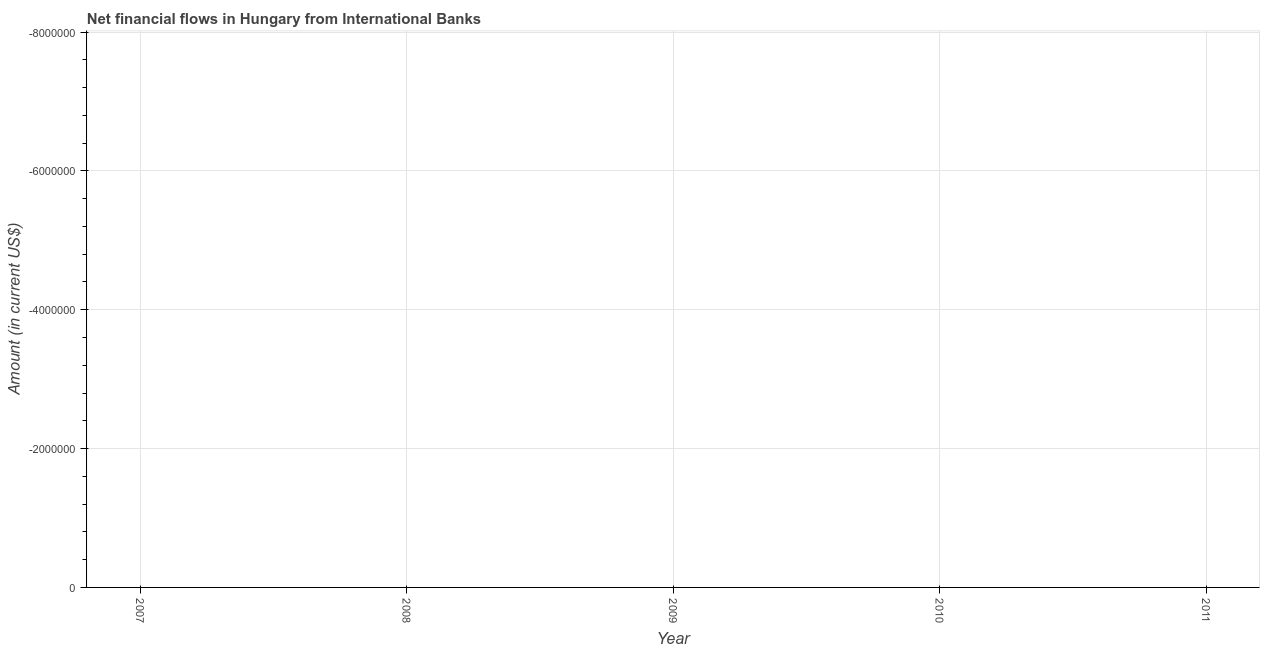Across all years, what is the minimum net financial flows from ibrd?
Offer a terse response. 0. Does the net financial flows from ibrd monotonically increase over the years?
Give a very brief answer. No. How many dotlines are there?
Ensure brevity in your answer.  0. How many years are there in the graph?
Your response must be concise. 5. Are the values on the major ticks of Y-axis written in scientific E-notation?
Give a very brief answer. No. Does the graph contain any zero values?
Offer a terse response. Yes. What is the title of the graph?
Provide a succinct answer. Net financial flows in Hungary from International Banks. What is the Amount (in current US$) in 2007?
Your answer should be very brief. 0. What is the Amount (in current US$) in 2009?
Your answer should be compact. 0. What is the Amount (in current US$) in 2010?
Your answer should be very brief. 0. 